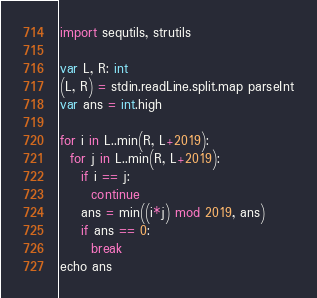<code> <loc_0><loc_0><loc_500><loc_500><_Nim_>import sequtils, strutils

var L, R: int
(L, R) = stdin.readLine.split.map parseInt
var ans = int.high

for i in L..min(R, L+2019):
  for j in L..min(R, L+2019):
    if i == j:
      continue
    ans = min((i*j) mod 2019, ans)
    if ans == 0:
      break
echo ans
</code> 